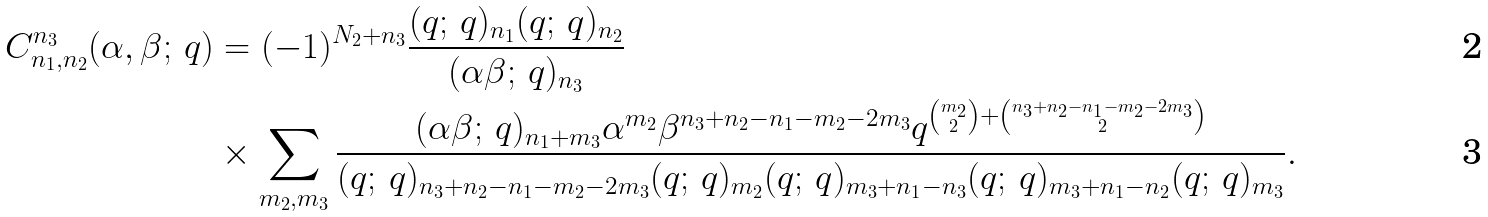<formula> <loc_0><loc_0><loc_500><loc_500>C _ { n _ { 1 } , n _ { 2 } } ^ { n _ { 3 } } ( \alpha , \beta ; \, q ) & = ( - 1 ) ^ { N _ { 2 } + n _ { 3 } } \frac { ( q ; \, q ) _ { n _ { 1 } } ( q ; \, q ) _ { n _ { 2 } } } { ( \alpha \beta ; \, q ) _ { n _ { 3 } } } \\ & \times \sum _ { m _ { 2 } , m _ { 3 } } \frac { ( \alpha \beta ; \, q ) _ { n _ { 1 } + m _ { 3 } } \alpha ^ { m _ { 2 } } \beta ^ { n _ { 3 } + n _ { 2 } - n _ { 1 } - m _ { 2 } - 2 m _ { 3 } } q ^ { { m _ { 2 } \choose 2 } + { n _ { 3 } + n _ { 2 } - n _ { 1 } - m _ { 2 } - 2 m _ { 3 } \choose 2 } } } { ( q ; \, q ) _ { n _ { 3 } + n _ { 2 } - n _ { 1 } - m _ { 2 } - 2 m _ { 3 } } ( q ; \, q ) _ { m _ { 2 } } ( q ; \, q ) _ { m _ { 3 } + n _ { 1 } - n _ { 3 } } ( q ; \, q ) _ { m _ { 3 } + n _ { 1 } - n _ { 2 } } ( q ; \, q ) _ { m _ { 3 } } } .</formula> 